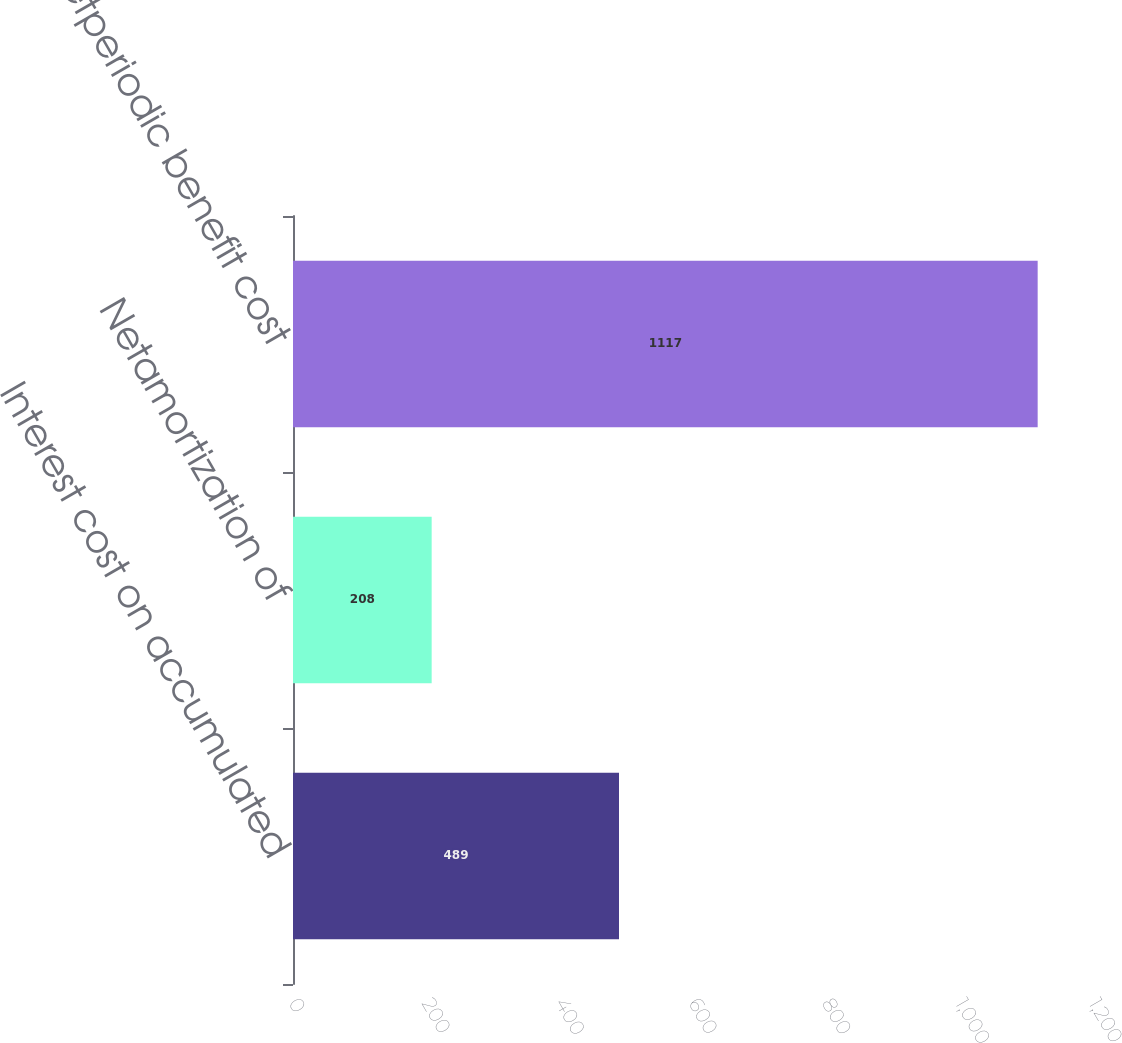<chart> <loc_0><loc_0><loc_500><loc_500><bar_chart><fcel>Interest cost on accumulated<fcel>Netamortization of<fcel>Netperiodic benefit cost<nl><fcel>489<fcel>208<fcel>1117<nl></chart> 